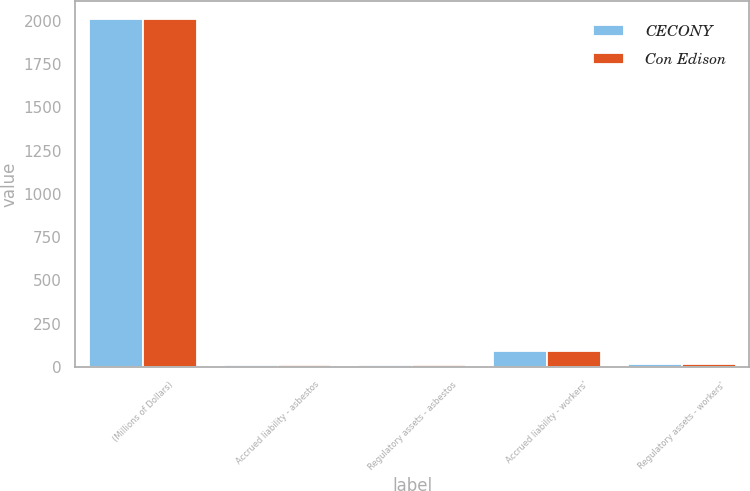Convert chart. <chart><loc_0><loc_0><loc_500><loc_500><stacked_bar_chart><ecel><fcel>(Millions of Dollars)<fcel>Accrued liability - asbestos<fcel>Regulatory assets - asbestos<fcel>Accrued liability - workers'<fcel>Regulatory assets - workers'<nl><fcel>CECONY<fcel>2012<fcel>10<fcel>10<fcel>94<fcel>19<nl><fcel>Con Edison<fcel>2012<fcel>10<fcel>10<fcel>89<fcel>19<nl></chart> 